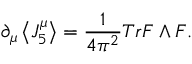Convert formula to latex. <formula><loc_0><loc_0><loc_500><loc_500>{ \partial } _ { \mu } \left \langle J _ { 5 } ^ { \mu } \right \rangle = \frac { 1 } { 4 { \pi ^ { 2 } } } T r F \wedge F .</formula> 